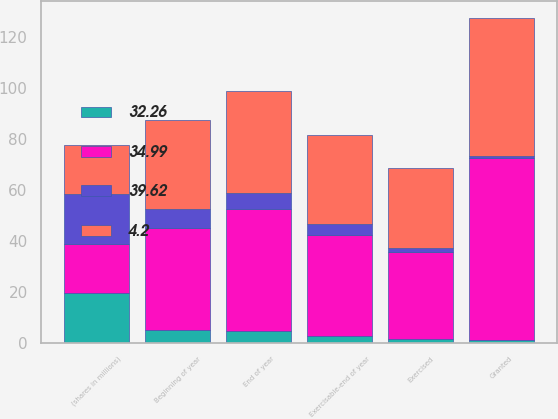<chart> <loc_0><loc_0><loc_500><loc_500><stacked_bar_chart><ecel><fcel>(shares in millions)<fcel>Beginning of year<fcel>Granted<fcel>Exercised<fcel>End of year<fcel>Exercisable-end of year<nl><fcel>32.26<fcel>19.415<fcel>5.1<fcel>0.9<fcel>1.3<fcel>4.6<fcel>2.7<nl><fcel>34.99<fcel>19.415<fcel>40.06<fcel>71.6<fcel>34.11<fcel>47.73<fcel>39.62<nl><fcel>4.2<fcel>19.415<fcel>34.98<fcel>54.27<fcel>31.43<fcel>40.06<fcel>34.99<nl><fcel>39.62<fcel>19.415<fcel>7.4<fcel>1<fcel>1.7<fcel>6.6<fcel>4.2<nl></chart> 